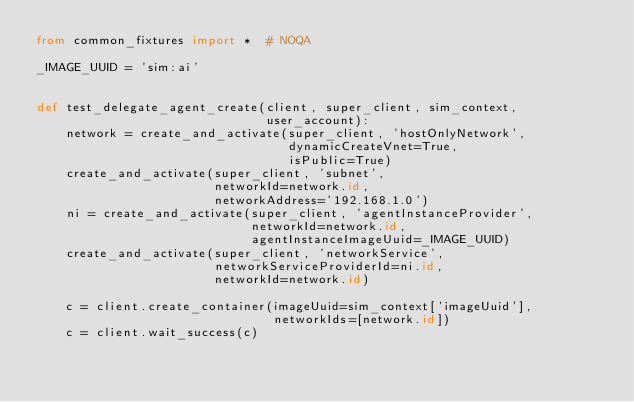Convert code to text. <code><loc_0><loc_0><loc_500><loc_500><_Python_>from common_fixtures import *  # NOQA

_IMAGE_UUID = 'sim:ai'


def test_delegate_agent_create(client, super_client, sim_context,
                               user_account):
    network = create_and_activate(super_client, 'hostOnlyNetwork',
                                  dynamicCreateVnet=True,
                                  isPublic=True)
    create_and_activate(super_client, 'subnet',
                        networkId=network.id,
                        networkAddress='192.168.1.0')
    ni = create_and_activate(super_client, 'agentInstanceProvider',
                             networkId=network.id,
                             agentInstanceImageUuid=_IMAGE_UUID)
    create_and_activate(super_client, 'networkService',
                        networkServiceProviderId=ni.id,
                        networkId=network.id)

    c = client.create_container(imageUuid=sim_context['imageUuid'],
                                networkIds=[network.id])
    c = client.wait_success(c)</code> 